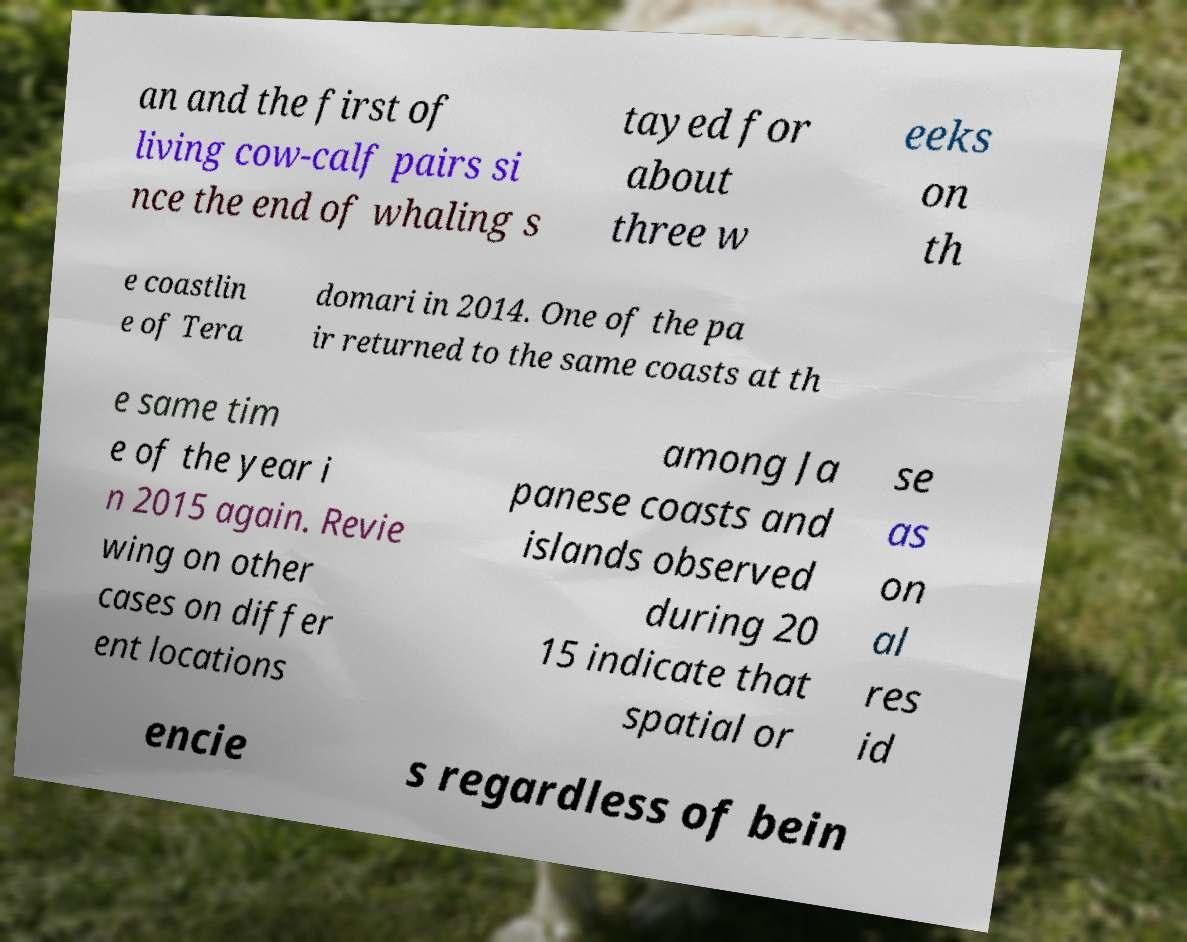Please read and relay the text visible in this image. What does it say? an and the first of living cow-calf pairs si nce the end of whaling s tayed for about three w eeks on th e coastlin e of Tera domari in 2014. One of the pa ir returned to the same coasts at th e same tim e of the year i n 2015 again. Revie wing on other cases on differ ent locations among Ja panese coasts and islands observed during 20 15 indicate that spatial or se as on al res id encie s regardless of bein 